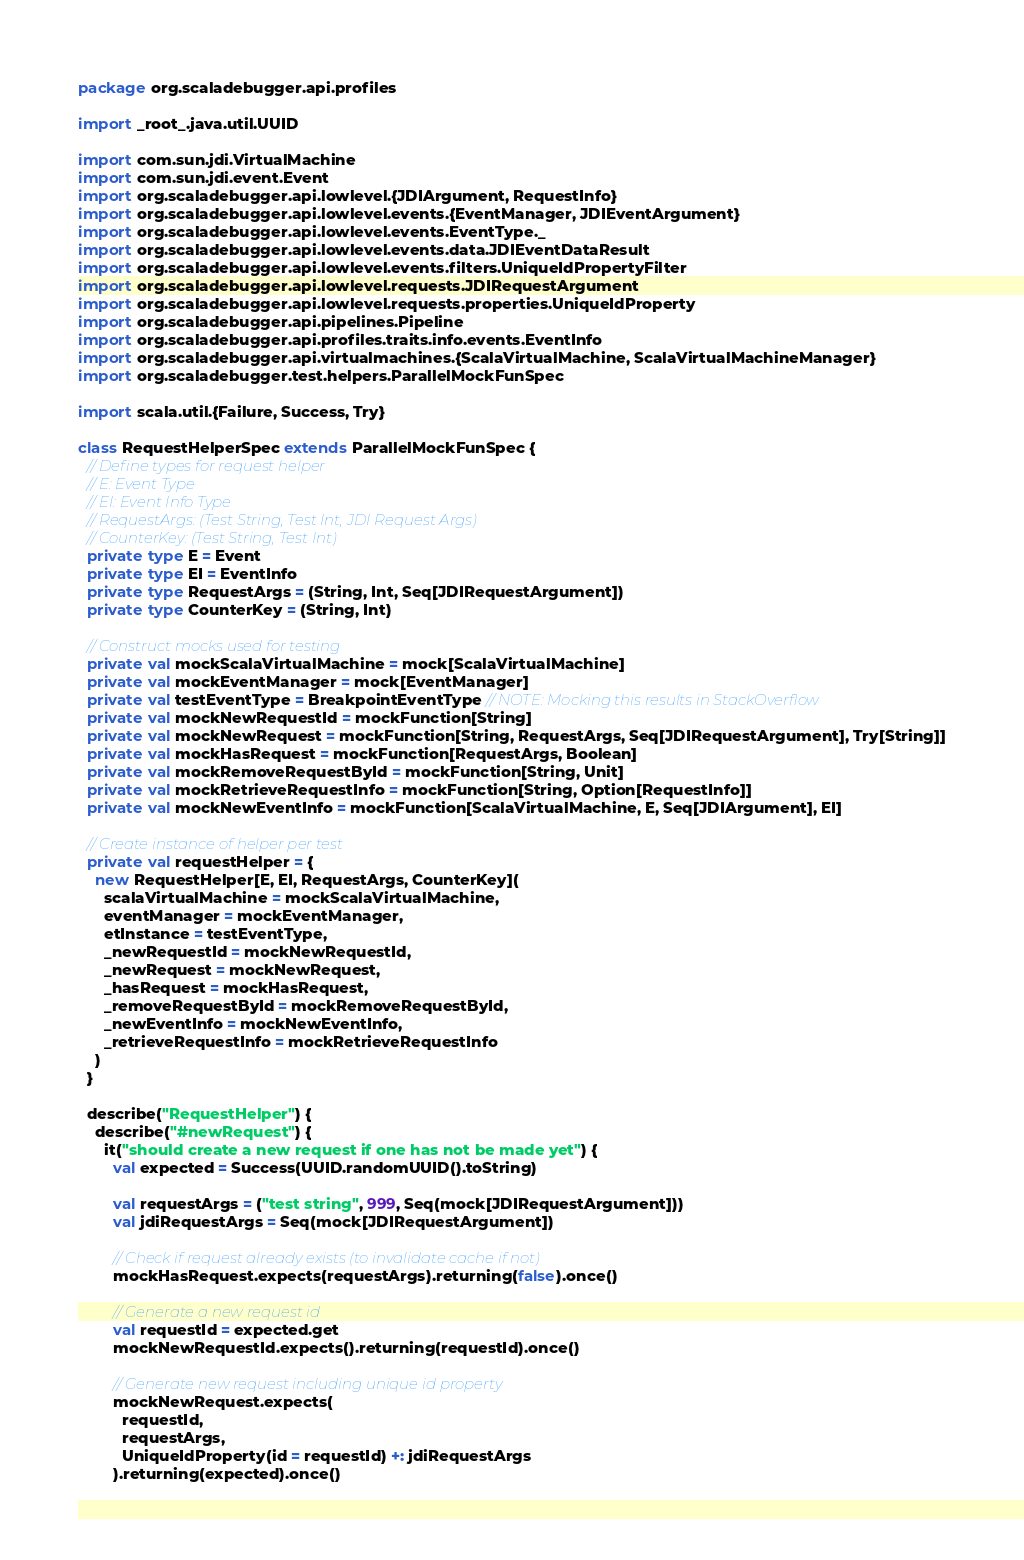Convert code to text. <code><loc_0><loc_0><loc_500><loc_500><_Scala_>package org.scaladebugger.api.profiles

import _root_.java.util.UUID

import com.sun.jdi.VirtualMachine
import com.sun.jdi.event.Event
import org.scaladebugger.api.lowlevel.{JDIArgument, RequestInfo}
import org.scaladebugger.api.lowlevel.events.{EventManager, JDIEventArgument}
import org.scaladebugger.api.lowlevel.events.EventType._
import org.scaladebugger.api.lowlevel.events.data.JDIEventDataResult
import org.scaladebugger.api.lowlevel.events.filters.UniqueIdPropertyFilter
import org.scaladebugger.api.lowlevel.requests.JDIRequestArgument
import org.scaladebugger.api.lowlevel.requests.properties.UniqueIdProperty
import org.scaladebugger.api.pipelines.Pipeline
import org.scaladebugger.api.profiles.traits.info.events.EventInfo
import org.scaladebugger.api.virtualmachines.{ScalaVirtualMachine, ScalaVirtualMachineManager}
import org.scaladebugger.test.helpers.ParallelMockFunSpec

import scala.util.{Failure, Success, Try}

class RequestHelperSpec extends ParallelMockFunSpec {
  // Define types for request helper
  // E: Event Type
  // EI: Event Info Type
  // RequestArgs: (Test String, Test Int, JDI Request Args)
  // CounterKey: (Test String, Test Int)
  private type E = Event
  private type EI = EventInfo
  private type RequestArgs = (String, Int, Seq[JDIRequestArgument])
  private type CounterKey = (String, Int)

  // Construct mocks used for testing
  private val mockScalaVirtualMachine = mock[ScalaVirtualMachine]
  private val mockEventManager = mock[EventManager]
  private val testEventType = BreakpointEventType // NOTE: Mocking this results in StackOverflow
  private val mockNewRequestId = mockFunction[String]
  private val mockNewRequest = mockFunction[String, RequestArgs, Seq[JDIRequestArgument], Try[String]]
  private val mockHasRequest = mockFunction[RequestArgs, Boolean]
  private val mockRemoveRequestById = mockFunction[String, Unit]
  private val mockRetrieveRequestInfo = mockFunction[String, Option[RequestInfo]]
  private val mockNewEventInfo = mockFunction[ScalaVirtualMachine, E, Seq[JDIArgument], EI]

  // Create instance of helper per test
  private val requestHelper = {
    new RequestHelper[E, EI, RequestArgs, CounterKey](
      scalaVirtualMachine = mockScalaVirtualMachine,
      eventManager = mockEventManager,
      etInstance = testEventType,
      _newRequestId = mockNewRequestId,
      _newRequest = mockNewRequest,
      _hasRequest = mockHasRequest,
      _removeRequestById = mockRemoveRequestById,
      _newEventInfo = mockNewEventInfo,
      _retrieveRequestInfo = mockRetrieveRequestInfo
    )
  }

  describe("RequestHelper") {
    describe("#newRequest") {
      it("should create a new request if one has not be made yet") {
        val expected = Success(UUID.randomUUID().toString)

        val requestArgs = ("test string", 999, Seq(mock[JDIRequestArgument]))
        val jdiRequestArgs = Seq(mock[JDIRequestArgument])

        // Check if request already exists (to invalidate cache if not)
        mockHasRequest.expects(requestArgs).returning(false).once()

        // Generate a new request id
        val requestId = expected.get
        mockNewRequestId.expects().returning(requestId).once()

        // Generate new request including unique id property
        mockNewRequest.expects(
          requestId,
          requestArgs,
          UniqueIdProperty(id = requestId) +: jdiRequestArgs
        ).returning(expected).once()
</code> 